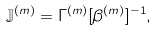Convert formula to latex. <formula><loc_0><loc_0><loc_500><loc_500>\mathbb { J } ^ { ( m ) } = \Gamma ^ { ( m ) } [ \beta ^ { ( m ) } ] ^ { - 1 } ,</formula> 